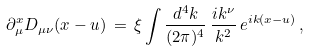Convert formula to latex. <formula><loc_0><loc_0><loc_500><loc_500>\partial ^ { x } _ { \mu } D _ { \mu \nu } ( x - u ) \, = \, \xi \int \frac { d ^ { 4 } k } { ( 2 \pi ) ^ { 4 } } \, \frac { i k ^ { \nu } } { k ^ { 2 } } \, e ^ { i k ( x - u ) } \, ,</formula> 